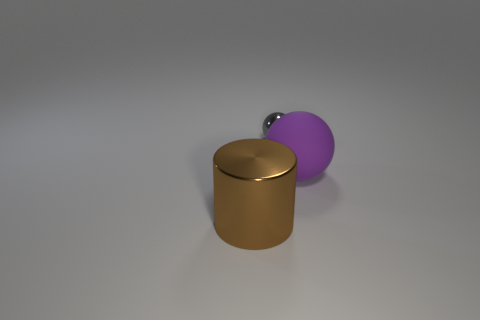The purple thing has what shape?
Your answer should be very brief. Sphere. There is a large thing to the left of the small gray sphere; does it have the same color as the small metallic sphere?
Provide a succinct answer. No. There is a object that is to the left of the large purple matte object and in front of the gray metallic sphere; what is its shape?
Offer a terse response. Cylinder. What color is the shiny thing that is behind the matte ball?
Your answer should be compact. Gray. Are there any other things that have the same color as the shiny cylinder?
Your response must be concise. No. Is the size of the brown metal object the same as the rubber sphere?
Offer a terse response. Yes. What size is the thing that is in front of the small ball and right of the brown metal thing?
Offer a very short reply. Large. How many big things have the same material as the tiny ball?
Keep it short and to the point. 1. What color is the big shiny thing?
Keep it short and to the point. Brown. There is a big object that is to the right of the big brown thing; is it the same shape as the small object?
Make the answer very short. Yes. 